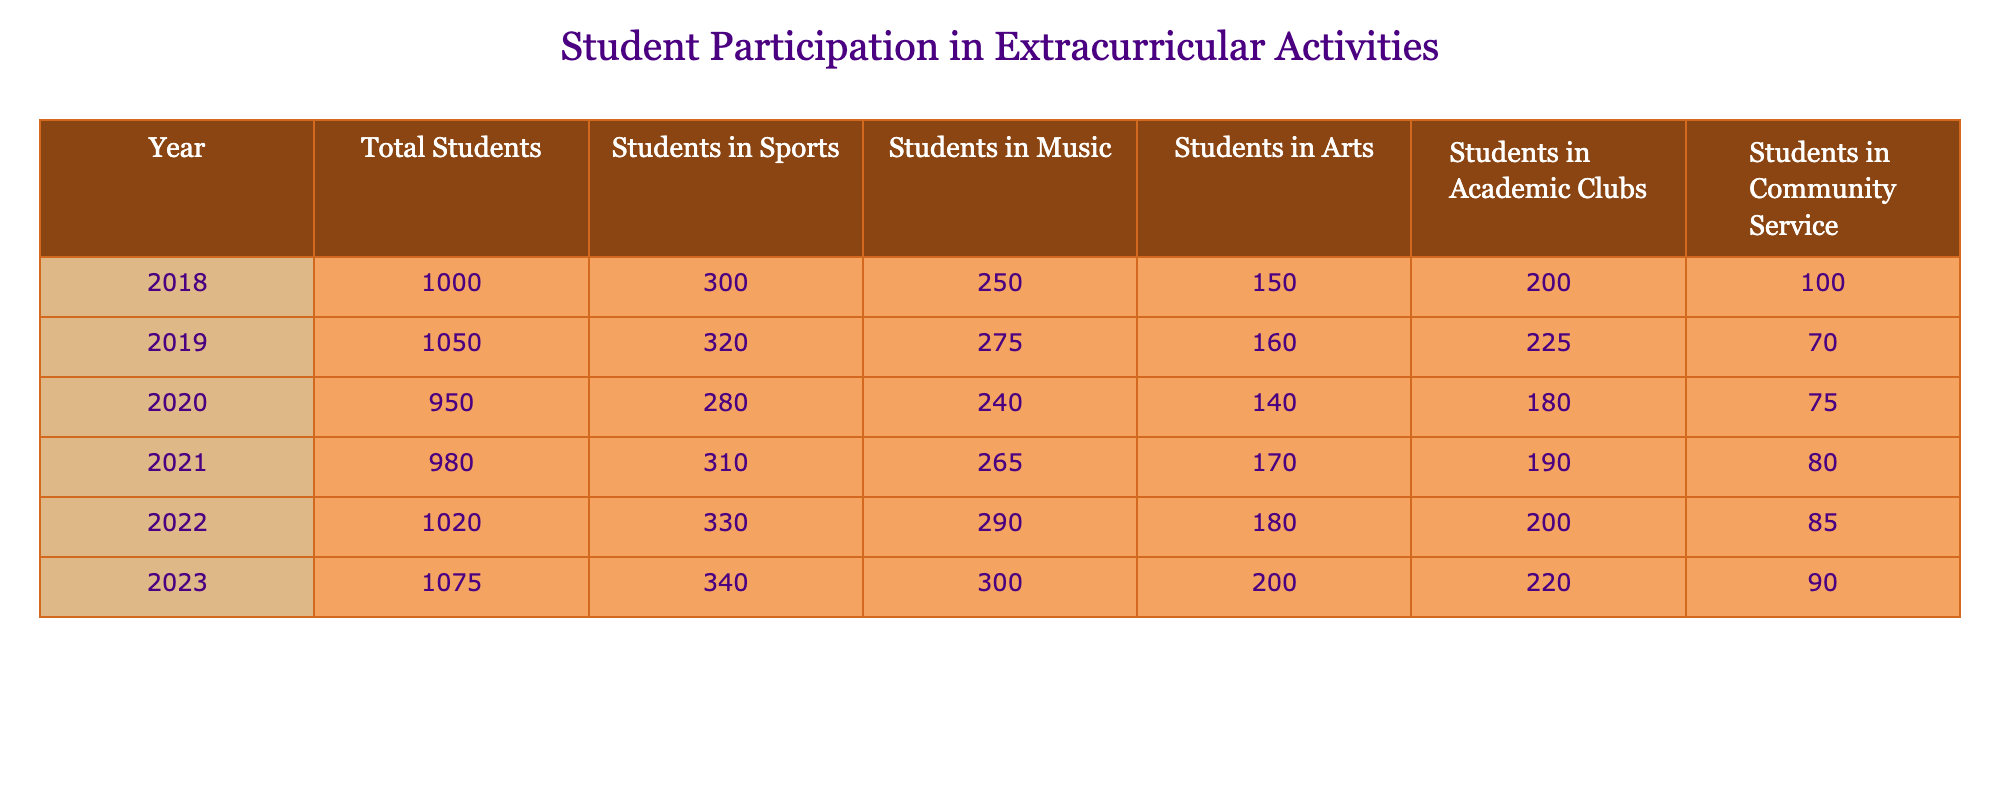What was the total number of students participating in extracurricular activities in 2022? The table shows that in 2022, the total number of students was 1,020. This value is directly referenced in the "Total Students" column for the year 2022.
Answer: 1,020 Which year had the highest number of students in sports? Looking at the "Students in Sports" column, the values are 300 (2018), 320 (2019), 280 (2020), 310 (2021), 330 (2022), and 340 (2023). The highest value is 340, which occurred in 2023.
Answer: 2023 How many students participated in music in 2020 compared to 2023? In 2020, the number of students in music was 240, while in 2023 it was 300. The difference can be calculated as 300 - 240 = 60.
Answer: 60 Was there a decrease in the number of students in community service from 2019 to 2020? In 2019, there were 70 students in community service, and in 2020, there were 75. Since 75 is greater than 70, it indicates an increase, not a decrease.
Answer: No What is the average number of students involved in arts over the years? The values for arts are 150 (2018), 160 (2019), 140 (2020), 170 (2021), 180 (2022), and 200 (2023). Adding these values gives us 1,100, and dividing by the number of years (6) gives us an average of 1,100 / 6 = 183.33. Rounding off, we find approximately 183.
Answer: 183 In which year did the participation in academic clubs first exceed 200 students? The "Students in Academic Clubs" column shows values of 200 (2018), 225 (2019), 180 (2020), 190 (2021), 200 (2022), and 220 (2023). The first time it exceeded 200 was in 2019 when it reached 225.
Answer: 2019 What was the total increase in student participation in sports from 2018 to 2023? In 2018, there were 300 students in sports, and in 2023, there were 340. The total increase is calculated as 340 - 300 = 40.
Answer: 40 Is it true that student participation in community service has been consistently increasing every year? The values for community service are 100 (2018), 70 (2019), 75 (2020), 80 (2021), 85 (2022), and 90 (2023). Since the number decreased from 100 to 70 in 2019, it is false to say participation has been consistently increasing.
Answer: No What was the percentage increase in total students from 2018 to 2023? The total number of students in 2018 was 1,000, and in 2023, it was 1,075. The increase is 1,075 - 1,000 = 75. To find the percentage increase, we calculate (75 / 1,000) * 100, which equals 7.5%.
Answer: 7.5% Which activity had the lowest participation in 2021? The values for each category in 2021 are: Sports (310), Music (265), Arts (170), Academic Clubs (190), and Community Service (80). The lowest number is 80 in Community Service.
Answer: Community Service 